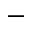<formula> <loc_0><loc_0><loc_500><loc_500>-</formula> 